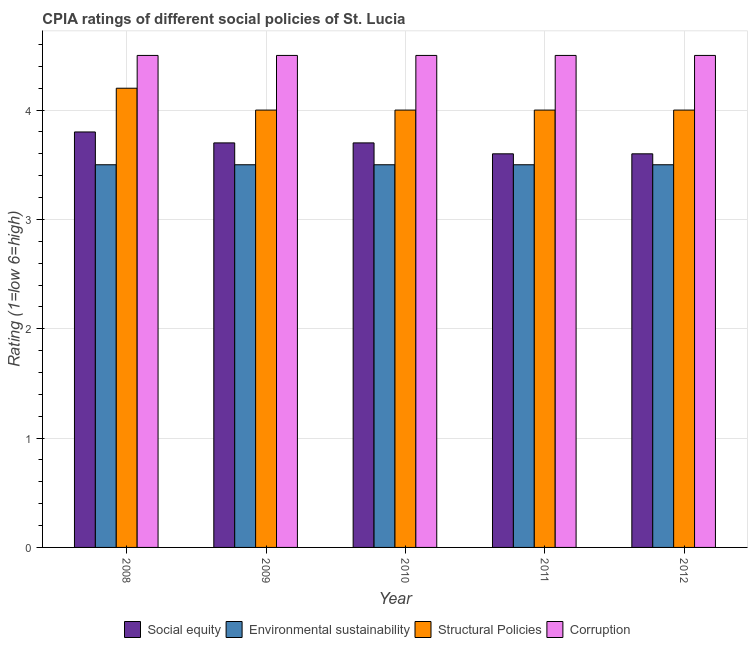How many groups of bars are there?
Provide a short and direct response. 5. How many bars are there on the 5th tick from the right?
Give a very brief answer. 4. What is the label of the 2nd group of bars from the left?
Your response must be concise. 2009. In how many cases, is the number of bars for a given year not equal to the number of legend labels?
Give a very brief answer. 0. In which year was the cpia rating of social equity maximum?
Make the answer very short. 2008. What is the difference between the cpia rating of structural policies in 2008 and the cpia rating of corruption in 2009?
Your answer should be compact. 0.2. What is the average cpia rating of social equity per year?
Your response must be concise. 3.68. In the year 2008, what is the difference between the cpia rating of environmental sustainability and cpia rating of corruption?
Ensure brevity in your answer.  0. What is the ratio of the cpia rating of structural policies in 2008 to that in 2009?
Offer a terse response. 1.05. Is the cpia rating of social equity in 2009 less than that in 2012?
Make the answer very short. No. What is the difference between the highest and the second highest cpia rating of environmental sustainability?
Ensure brevity in your answer.  0. In how many years, is the cpia rating of corruption greater than the average cpia rating of corruption taken over all years?
Give a very brief answer. 0. Is it the case that in every year, the sum of the cpia rating of environmental sustainability and cpia rating of structural policies is greater than the sum of cpia rating of social equity and cpia rating of corruption?
Your answer should be compact. No. What does the 3rd bar from the left in 2010 represents?
Your response must be concise. Structural Policies. What does the 1st bar from the right in 2008 represents?
Provide a short and direct response. Corruption. How many bars are there?
Ensure brevity in your answer.  20. What is the difference between two consecutive major ticks on the Y-axis?
Make the answer very short. 1. Are the values on the major ticks of Y-axis written in scientific E-notation?
Your answer should be very brief. No. Does the graph contain grids?
Your answer should be compact. Yes. Where does the legend appear in the graph?
Give a very brief answer. Bottom center. What is the title of the graph?
Provide a short and direct response. CPIA ratings of different social policies of St. Lucia. Does "Overall level" appear as one of the legend labels in the graph?
Offer a terse response. No. What is the label or title of the X-axis?
Your response must be concise. Year. What is the label or title of the Y-axis?
Offer a very short reply. Rating (1=low 6=high). What is the Rating (1=low 6=high) in Environmental sustainability in 2008?
Your answer should be compact. 3.5. What is the Rating (1=low 6=high) in Structural Policies in 2008?
Ensure brevity in your answer.  4.2. What is the Rating (1=low 6=high) of Corruption in 2008?
Make the answer very short. 4.5. What is the Rating (1=low 6=high) in Social equity in 2009?
Keep it short and to the point. 3.7. What is the Rating (1=low 6=high) in Environmental sustainability in 2009?
Offer a terse response. 3.5. What is the Rating (1=low 6=high) of Social equity in 2010?
Offer a very short reply. 3.7. What is the Rating (1=low 6=high) in Environmental sustainability in 2010?
Offer a very short reply. 3.5. What is the Rating (1=low 6=high) of Corruption in 2010?
Your answer should be compact. 4.5. What is the Rating (1=low 6=high) in Environmental sustainability in 2011?
Keep it short and to the point. 3.5. What is the Rating (1=low 6=high) in Corruption in 2011?
Offer a very short reply. 4.5. What is the Rating (1=low 6=high) in Social equity in 2012?
Offer a terse response. 3.6. What is the Rating (1=low 6=high) of Environmental sustainability in 2012?
Keep it short and to the point. 3.5. Across all years, what is the maximum Rating (1=low 6=high) in Social equity?
Offer a very short reply. 3.8. Across all years, what is the maximum Rating (1=low 6=high) in Corruption?
Offer a very short reply. 4.5. Across all years, what is the minimum Rating (1=low 6=high) of Structural Policies?
Your response must be concise. 4. What is the total Rating (1=low 6=high) in Social equity in the graph?
Provide a short and direct response. 18.4. What is the total Rating (1=low 6=high) in Structural Policies in the graph?
Your answer should be very brief. 20.2. What is the difference between the Rating (1=low 6=high) in Social equity in 2008 and that in 2009?
Offer a very short reply. 0.1. What is the difference between the Rating (1=low 6=high) of Environmental sustainability in 2008 and that in 2009?
Your response must be concise. 0. What is the difference between the Rating (1=low 6=high) in Structural Policies in 2008 and that in 2009?
Make the answer very short. 0.2. What is the difference between the Rating (1=low 6=high) of Social equity in 2008 and that in 2010?
Make the answer very short. 0.1. What is the difference between the Rating (1=low 6=high) in Corruption in 2008 and that in 2010?
Provide a succinct answer. 0. What is the difference between the Rating (1=low 6=high) of Environmental sustainability in 2008 and that in 2011?
Keep it short and to the point. 0. What is the difference between the Rating (1=low 6=high) in Structural Policies in 2008 and that in 2011?
Give a very brief answer. 0.2. What is the difference between the Rating (1=low 6=high) in Environmental sustainability in 2008 and that in 2012?
Offer a very short reply. 0. What is the difference between the Rating (1=low 6=high) of Structural Policies in 2008 and that in 2012?
Provide a short and direct response. 0.2. What is the difference between the Rating (1=low 6=high) in Corruption in 2008 and that in 2012?
Keep it short and to the point. 0. What is the difference between the Rating (1=low 6=high) in Social equity in 2009 and that in 2010?
Make the answer very short. 0. What is the difference between the Rating (1=low 6=high) in Structural Policies in 2009 and that in 2010?
Your answer should be compact. 0. What is the difference between the Rating (1=low 6=high) of Corruption in 2009 and that in 2010?
Keep it short and to the point. 0. What is the difference between the Rating (1=low 6=high) in Social equity in 2009 and that in 2011?
Your response must be concise. 0.1. What is the difference between the Rating (1=low 6=high) in Environmental sustainability in 2009 and that in 2011?
Your answer should be very brief. 0. What is the difference between the Rating (1=low 6=high) of Structural Policies in 2009 and that in 2011?
Your answer should be very brief. 0. What is the difference between the Rating (1=low 6=high) of Corruption in 2009 and that in 2011?
Offer a very short reply. 0. What is the difference between the Rating (1=low 6=high) in Social equity in 2009 and that in 2012?
Give a very brief answer. 0.1. What is the difference between the Rating (1=low 6=high) in Environmental sustainability in 2009 and that in 2012?
Keep it short and to the point. 0. What is the difference between the Rating (1=low 6=high) in Social equity in 2010 and that in 2011?
Give a very brief answer. 0.1. What is the difference between the Rating (1=low 6=high) in Environmental sustainability in 2010 and that in 2011?
Offer a terse response. 0. What is the difference between the Rating (1=low 6=high) of Structural Policies in 2010 and that in 2011?
Offer a very short reply. 0. What is the difference between the Rating (1=low 6=high) in Social equity in 2010 and that in 2012?
Your answer should be very brief. 0.1. What is the difference between the Rating (1=low 6=high) of Social equity in 2011 and that in 2012?
Your response must be concise. 0. What is the difference between the Rating (1=low 6=high) of Social equity in 2008 and the Rating (1=low 6=high) of Corruption in 2009?
Ensure brevity in your answer.  -0.7. What is the difference between the Rating (1=low 6=high) in Environmental sustainability in 2008 and the Rating (1=low 6=high) in Structural Policies in 2009?
Provide a short and direct response. -0.5. What is the difference between the Rating (1=low 6=high) of Environmental sustainability in 2008 and the Rating (1=low 6=high) of Corruption in 2009?
Provide a succinct answer. -1. What is the difference between the Rating (1=low 6=high) in Social equity in 2008 and the Rating (1=low 6=high) in Environmental sustainability in 2010?
Provide a short and direct response. 0.3. What is the difference between the Rating (1=low 6=high) of Social equity in 2008 and the Rating (1=low 6=high) of Structural Policies in 2010?
Offer a very short reply. -0.2. What is the difference between the Rating (1=low 6=high) in Social equity in 2008 and the Rating (1=low 6=high) in Corruption in 2010?
Offer a very short reply. -0.7. What is the difference between the Rating (1=low 6=high) of Social equity in 2008 and the Rating (1=low 6=high) of Environmental sustainability in 2011?
Make the answer very short. 0.3. What is the difference between the Rating (1=low 6=high) in Social equity in 2008 and the Rating (1=low 6=high) in Structural Policies in 2011?
Make the answer very short. -0.2. What is the difference between the Rating (1=low 6=high) in Environmental sustainability in 2008 and the Rating (1=low 6=high) in Structural Policies in 2011?
Your response must be concise. -0.5. What is the difference between the Rating (1=low 6=high) in Environmental sustainability in 2008 and the Rating (1=low 6=high) in Corruption in 2011?
Your response must be concise. -1. What is the difference between the Rating (1=low 6=high) in Environmental sustainability in 2008 and the Rating (1=low 6=high) in Structural Policies in 2012?
Provide a short and direct response. -0.5. What is the difference between the Rating (1=low 6=high) in Environmental sustainability in 2008 and the Rating (1=low 6=high) in Corruption in 2012?
Give a very brief answer. -1. What is the difference between the Rating (1=low 6=high) of Social equity in 2009 and the Rating (1=low 6=high) of Structural Policies in 2010?
Provide a succinct answer. -0.3. What is the difference between the Rating (1=low 6=high) in Social equity in 2009 and the Rating (1=low 6=high) in Corruption in 2010?
Ensure brevity in your answer.  -0.8. What is the difference between the Rating (1=low 6=high) in Environmental sustainability in 2009 and the Rating (1=low 6=high) in Corruption in 2010?
Your answer should be very brief. -1. What is the difference between the Rating (1=low 6=high) of Structural Policies in 2009 and the Rating (1=low 6=high) of Corruption in 2010?
Offer a terse response. -0.5. What is the difference between the Rating (1=low 6=high) in Social equity in 2009 and the Rating (1=low 6=high) in Environmental sustainability in 2011?
Offer a very short reply. 0.2. What is the difference between the Rating (1=low 6=high) of Social equity in 2009 and the Rating (1=low 6=high) of Structural Policies in 2011?
Offer a very short reply. -0.3. What is the difference between the Rating (1=low 6=high) in Environmental sustainability in 2009 and the Rating (1=low 6=high) in Structural Policies in 2011?
Your answer should be very brief. -0.5. What is the difference between the Rating (1=low 6=high) of Social equity in 2009 and the Rating (1=low 6=high) of Environmental sustainability in 2012?
Ensure brevity in your answer.  0.2. What is the difference between the Rating (1=low 6=high) in Structural Policies in 2009 and the Rating (1=low 6=high) in Corruption in 2012?
Keep it short and to the point. -0.5. What is the difference between the Rating (1=low 6=high) in Social equity in 2010 and the Rating (1=low 6=high) in Environmental sustainability in 2011?
Offer a terse response. 0.2. What is the difference between the Rating (1=low 6=high) in Social equity in 2010 and the Rating (1=low 6=high) in Corruption in 2011?
Your answer should be compact. -0.8. What is the difference between the Rating (1=low 6=high) of Environmental sustainability in 2010 and the Rating (1=low 6=high) of Structural Policies in 2011?
Make the answer very short. -0.5. What is the difference between the Rating (1=low 6=high) of Social equity in 2010 and the Rating (1=low 6=high) of Environmental sustainability in 2012?
Provide a short and direct response. 0.2. What is the difference between the Rating (1=low 6=high) of Environmental sustainability in 2010 and the Rating (1=low 6=high) of Structural Policies in 2012?
Offer a very short reply. -0.5. What is the difference between the Rating (1=low 6=high) of Structural Policies in 2010 and the Rating (1=low 6=high) of Corruption in 2012?
Provide a succinct answer. -0.5. What is the difference between the Rating (1=low 6=high) in Social equity in 2011 and the Rating (1=low 6=high) in Structural Policies in 2012?
Offer a very short reply. -0.4. What is the difference between the Rating (1=low 6=high) in Social equity in 2011 and the Rating (1=low 6=high) in Corruption in 2012?
Offer a very short reply. -0.9. What is the difference between the Rating (1=low 6=high) of Environmental sustainability in 2011 and the Rating (1=low 6=high) of Structural Policies in 2012?
Provide a short and direct response. -0.5. What is the difference between the Rating (1=low 6=high) in Environmental sustainability in 2011 and the Rating (1=low 6=high) in Corruption in 2012?
Give a very brief answer. -1. What is the difference between the Rating (1=low 6=high) of Structural Policies in 2011 and the Rating (1=low 6=high) of Corruption in 2012?
Make the answer very short. -0.5. What is the average Rating (1=low 6=high) in Social equity per year?
Offer a very short reply. 3.68. What is the average Rating (1=low 6=high) of Structural Policies per year?
Your answer should be very brief. 4.04. In the year 2008, what is the difference between the Rating (1=low 6=high) in Environmental sustainability and Rating (1=low 6=high) in Structural Policies?
Ensure brevity in your answer.  -0.7. In the year 2008, what is the difference between the Rating (1=low 6=high) of Structural Policies and Rating (1=low 6=high) of Corruption?
Offer a very short reply. -0.3. In the year 2009, what is the difference between the Rating (1=low 6=high) in Social equity and Rating (1=low 6=high) in Structural Policies?
Your response must be concise. -0.3. In the year 2009, what is the difference between the Rating (1=low 6=high) of Social equity and Rating (1=low 6=high) of Corruption?
Offer a terse response. -0.8. In the year 2009, what is the difference between the Rating (1=low 6=high) of Environmental sustainability and Rating (1=low 6=high) of Corruption?
Offer a terse response. -1. In the year 2009, what is the difference between the Rating (1=low 6=high) in Structural Policies and Rating (1=low 6=high) in Corruption?
Your answer should be compact. -0.5. In the year 2010, what is the difference between the Rating (1=low 6=high) of Social equity and Rating (1=low 6=high) of Structural Policies?
Offer a very short reply. -0.3. In the year 2010, what is the difference between the Rating (1=low 6=high) in Social equity and Rating (1=low 6=high) in Corruption?
Make the answer very short. -0.8. In the year 2010, what is the difference between the Rating (1=low 6=high) in Environmental sustainability and Rating (1=low 6=high) in Structural Policies?
Your response must be concise. -0.5. In the year 2010, what is the difference between the Rating (1=low 6=high) of Environmental sustainability and Rating (1=low 6=high) of Corruption?
Your answer should be very brief. -1. In the year 2011, what is the difference between the Rating (1=low 6=high) of Social equity and Rating (1=low 6=high) of Environmental sustainability?
Offer a very short reply. 0.1. In the year 2011, what is the difference between the Rating (1=low 6=high) of Social equity and Rating (1=low 6=high) of Corruption?
Keep it short and to the point. -0.9. In the year 2011, what is the difference between the Rating (1=low 6=high) in Environmental sustainability and Rating (1=low 6=high) in Corruption?
Provide a succinct answer. -1. In the year 2011, what is the difference between the Rating (1=low 6=high) of Structural Policies and Rating (1=low 6=high) of Corruption?
Your answer should be compact. -0.5. In the year 2012, what is the difference between the Rating (1=low 6=high) of Social equity and Rating (1=low 6=high) of Environmental sustainability?
Your answer should be compact. 0.1. In the year 2012, what is the difference between the Rating (1=low 6=high) of Social equity and Rating (1=low 6=high) of Corruption?
Keep it short and to the point. -0.9. In the year 2012, what is the difference between the Rating (1=low 6=high) of Structural Policies and Rating (1=low 6=high) of Corruption?
Give a very brief answer. -0.5. What is the ratio of the Rating (1=low 6=high) of Environmental sustainability in 2008 to that in 2009?
Offer a terse response. 1. What is the ratio of the Rating (1=low 6=high) in Structural Policies in 2008 to that in 2009?
Give a very brief answer. 1.05. What is the ratio of the Rating (1=low 6=high) of Social equity in 2008 to that in 2010?
Offer a very short reply. 1.03. What is the ratio of the Rating (1=low 6=high) of Environmental sustainability in 2008 to that in 2010?
Give a very brief answer. 1. What is the ratio of the Rating (1=low 6=high) in Social equity in 2008 to that in 2011?
Your answer should be compact. 1.06. What is the ratio of the Rating (1=low 6=high) of Social equity in 2008 to that in 2012?
Your response must be concise. 1.06. What is the ratio of the Rating (1=low 6=high) in Environmental sustainability in 2008 to that in 2012?
Provide a succinct answer. 1. What is the ratio of the Rating (1=low 6=high) of Structural Policies in 2008 to that in 2012?
Ensure brevity in your answer.  1.05. What is the ratio of the Rating (1=low 6=high) in Corruption in 2008 to that in 2012?
Ensure brevity in your answer.  1. What is the ratio of the Rating (1=low 6=high) in Social equity in 2009 to that in 2010?
Your response must be concise. 1. What is the ratio of the Rating (1=low 6=high) of Environmental sustainability in 2009 to that in 2010?
Give a very brief answer. 1. What is the ratio of the Rating (1=low 6=high) of Corruption in 2009 to that in 2010?
Provide a short and direct response. 1. What is the ratio of the Rating (1=low 6=high) of Social equity in 2009 to that in 2011?
Offer a very short reply. 1.03. What is the ratio of the Rating (1=low 6=high) in Corruption in 2009 to that in 2011?
Keep it short and to the point. 1. What is the ratio of the Rating (1=low 6=high) of Social equity in 2009 to that in 2012?
Give a very brief answer. 1.03. What is the ratio of the Rating (1=low 6=high) of Environmental sustainability in 2009 to that in 2012?
Ensure brevity in your answer.  1. What is the ratio of the Rating (1=low 6=high) of Structural Policies in 2009 to that in 2012?
Give a very brief answer. 1. What is the ratio of the Rating (1=low 6=high) of Corruption in 2009 to that in 2012?
Your answer should be very brief. 1. What is the ratio of the Rating (1=low 6=high) in Social equity in 2010 to that in 2011?
Give a very brief answer. 1.03. What is the ratio of the Rating (1=low 6=high) in Environmental sustainability in 2010 to that in 2011?
Provide a short and direct response. 1. What is the ratio of the Rating (1=low 6=high) of Structural Policies in 2010 to that in 2011?
Your response must be concise. 1. What is the ratio of the Rating (1=low 6=high) in Social equity in 2010 to that in 2012?
Provide a short and direct response. 1.03. What is the ratio of the Rating (1=low 6=high) of Environmental sustainability in 2010 to that in 2012?
Give a very brief answer. 1. What is the ratio of the Rating (1=low 6=high) of Structural Policies in 2010 to that in 2012?
Give a very brief answer. 1. What is the ratio of the Rating (1=low 6=high) in Corruption in 2010 to that in 2012?
Offer a terse response. 1. What is the ratio of the Rating (1=low 6=high) in Social equity in 2011 to that in 2012?
Your response must be concise. 1. What is the ratio of the Rating (1=low 6=high) of Environmental sustainability in 2011 to that in 2012?
Offer a terse response. 1. What is the difference between the highest and the second highest Rating (1=low 6=high) in Environmental sustainability?
Provide a succinct answer. 0. What is the difference between the highest and the lowest Rating (1=low 6=high) in Environmental sustainability?
Make the answer very short. 0. What is the difference between the highest and the lowest Rating (1=low 6=high) in Structural Policies?
Ensure brevity in your answer.  0.2. What is the difference between the highest and the lowest Rating (1=low 6=high) of Corruption?
Ensure brevity in your answer.  0. 